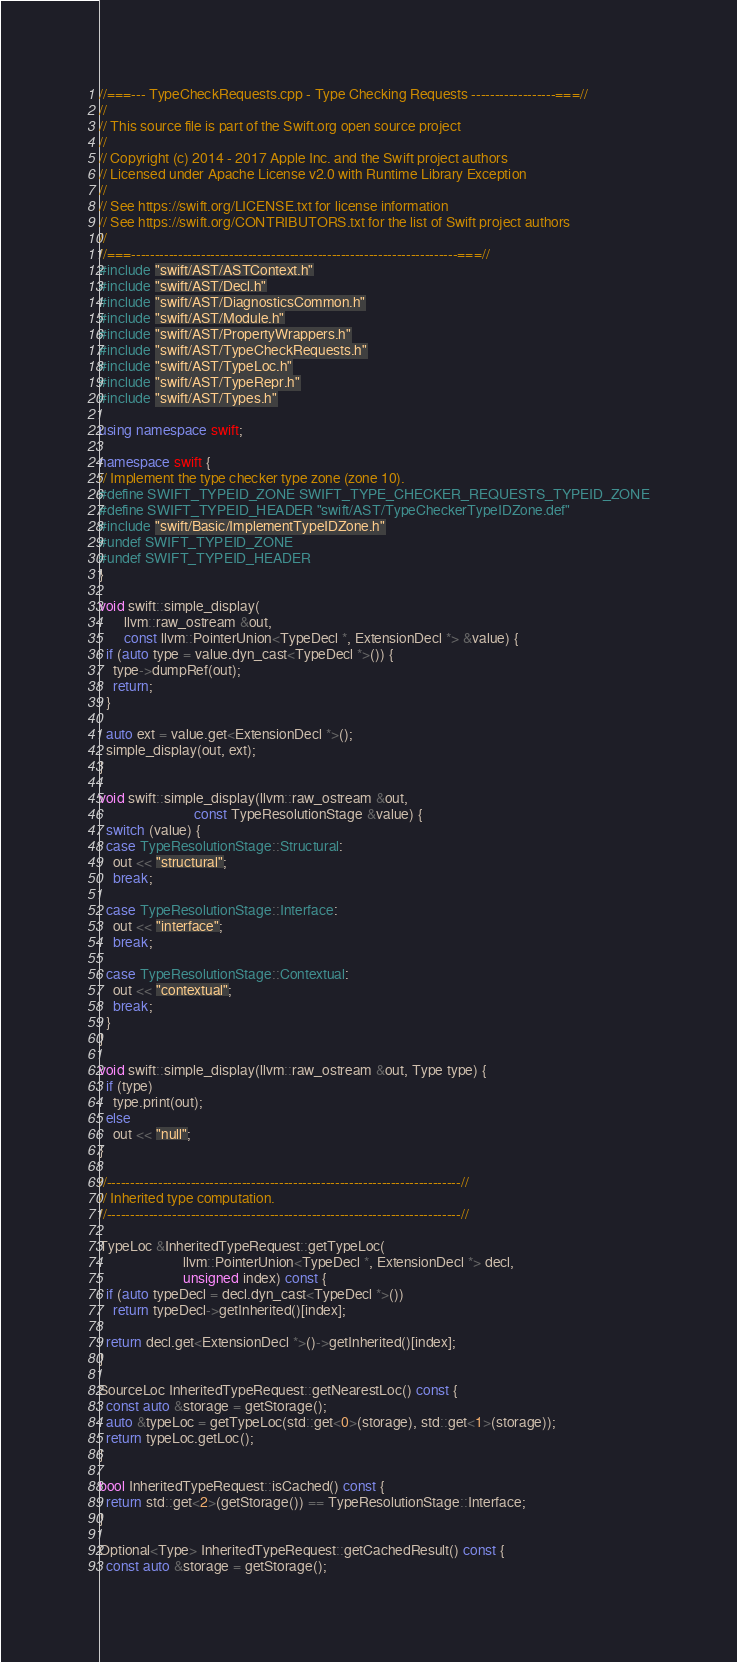Convert code to text. <code><loc_0><loc_0><loc_500><loc_500><_C++_>//===--- TypeCheckRequests.cpp - Type Checking Requests ------------------===//
//
// This source file is part of the Swift.org open source project
//
// Copyright (c) 2014 - 2017 Apple Inc. and the Swift project authors
// Licensed under Apache License v2.0 with Runtime Library Exception
//
// See https://swift.org/LICENSE.txt for license information
// See https://swift.org/CONTRIBUTORS.txt for the list of Swift project authors
//
//===----------------------------------------------------------------------===//
#include "swift/AST/ASTContext.h"
#include "swift/AST/Decl.h"
#include "swift/AST/DiagnosticsCommon.h"
#include "swift/AST/Module.h"
#include "swift/AST/PropertyWrappers.h"
#include "swift/AST/TypeCheckRequests.h"
#include "swift/AST/TypeLoc.h"
#include "swift/AST/TypeRepr.h"
#include "swift/AST/Types.h"

using namespace swift;

namespace swift {
// Implement the type checker type zone (zone 10).
#define SWIFT_TYPEID_ZONE SWIFT_TYPE_CHECKER_REQUESTS_TYPEID_ZONE
#define SWIFT_TYPEID_HEADER "swift/AST/TypeCheckerTypeIDZone.def"
#include "swift/Basic/ImplementTypeIDZone.h"
#undef SWIFT_TYPEID_ZONE
#undef SWIFT_TYPEID_HEADER
}

void swift::simple_display(
       llvm::raw_ostream &out,
       const llvm::PointerUnion<TypeDecl *, ExtensionDecl *> &value) {
  if (auto type = value.dyn_cast<TypeDecl *>()) {
    type->dumpRef(out);
    return;
  }

  auto ext = value.get<ExtensionDecl *>();
  simple_display(out, ext);
}

void swift::simple_display(llvm::raw_ostream &out,
                           const TypeResolutionStage &value) {
  switch (value) {
  case TypeResolutionStage::Structural:
    out << "structural";
    break;

  case TypeResolutionStage::Interface:
    out << "interface";
    break;

  case TypeResolutionStage::Contextual:
    out << "contextual";
    break;
  }
}

void swift::simple_display(llvm::raw_ostream &out, Type type) {
  if (type)
    type.print(out);
  else
    out << "null";
}

//----------------------------------------------------------------------------//
// Inherited type computation.
//----------------------------------------------------------------------------//

TypeLoc &InheritedTypeRequest::getTypeLoc(
                        llvm::PointerUnion<TypeDecl *, ExtensionDecl *> decl,
                        unsigned index) const {
  if (auto typeDecl = decl.dyn_cast<TypeDecl *>())
    return typeDecl->getInherited()[index];

  return decl.get<ExtensionDecl *>()->getInherited()[index];
}

SourceLoc InheritedTypeRequest::getNearestLoc() const {
  const auto &storage = getStorage();
  auto &typeLoc = getTypeLoc(std::get<0>(storage), std::get<1>(storage));
  return typeLoc.getLoc();
}

bool InheritedTypeRequest::isCached() const {
  return std::get<2>(getStorage()) == TypeResolutionStage::Interface;
}

Optional<Type> InheritedTypeRequest::getCachedResult() const {
  const auto &storage = getStorage();</code> 